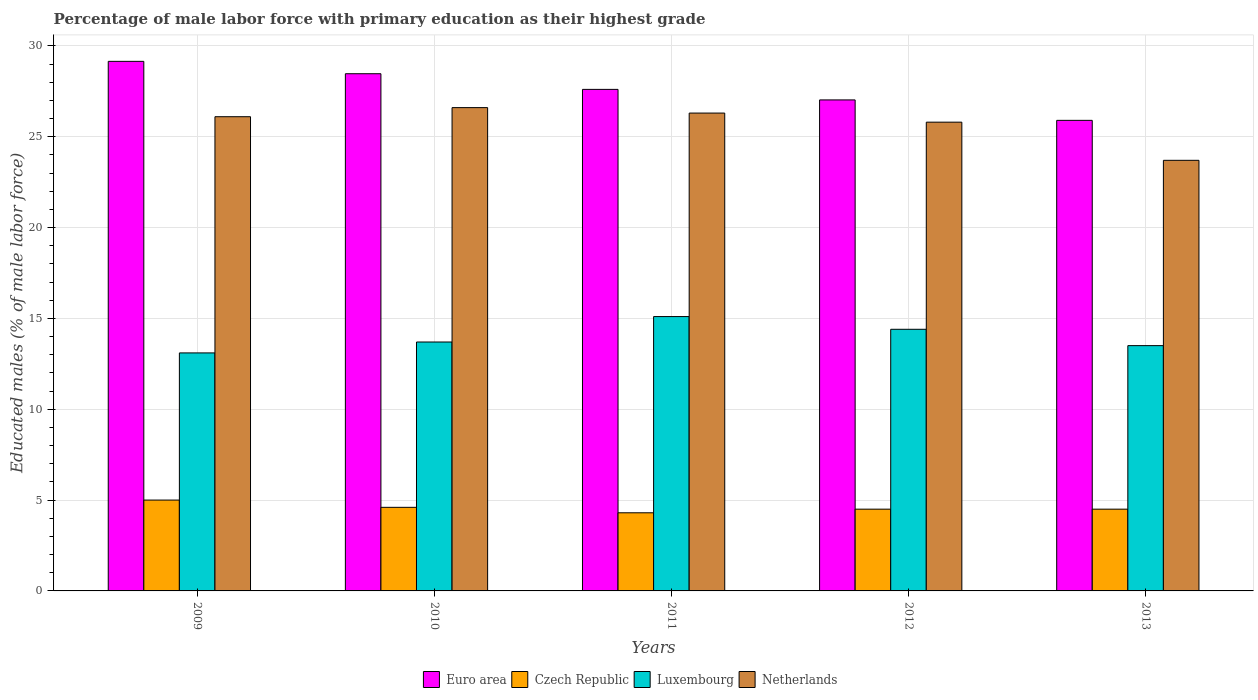How many different coloured bars are there?
Keep it short and to the point. 4. How many bars are there on the 5th tick from the left?
Give a very brief answer. 4. How many bars are there on the 1st tick from the right?
Provide a short and direct response. 4. In how many cases, is the number of bars for a given year not equal to the number of legend labels?
Offer a very short reply. 0. What is the percentage of male labor force with primary education in Netherlands in 2013?
Make the answer very short. 23.7. Across all years, what is the maximum percentage of male labor force with primary education in Luxembourg?
Ensure brevity in your answer.  15.1. Across all years, what is the minimum percentage of male labor force with primary education in Luxembourg?
Make the answer very short. 13.1. What is the total percentage of male labor force with primary education in Euro area in the graph?
Keep it short and to the point. 138.14. What is the difference between the percentage of male labor force with primary education in Luxembourg in 2009 and that in 2010?
Your answer should be very brief. -0.6. What is the difference between the percentage of male labor force with primary education in Euro area in 2010 and the percentage of male labor force with primary education in Netherlands in 2013?
Keep it short and to the point. 4.77. What is the average percentage of male labor force with primary education in Euro area per year?
Offer a very short reply. 27.63. In the year 2009, what is the difference between the percentage of male labor force with primary education in Czech Republic and percentage of male labor force with primary education in Luxembourg?
Provide a succinct answer. -8.1. What is the ratio of the percentage of male labor force with primary education in Euro area in 2009 to that in 2012?
Provide a succinct answer. 1.08. What is the difference between the highest and the second highest percentage of male labor force with primary education in Euro area?
Your answer should be very brief. 0.68. What is the difference between the highest and the lowest percentage of male labor force with primary education in Euro area?
Give a very brief answer. 3.25. Is the sum of the percentage of male labor force with primary education in Netherlands in 2009 and 2011 greater than the maximum percentage of male labor force with primary education in Euro area across all years?
Your answer should be very brief. Yes. What does the 1st bar from the left in 2012 represents?
Offer a terse response. Euro area. Is it the case that in every year, the sum of the percentage of male labor force with primary education in Luxembourg and percentage of male labor force with primary education in Czech Republic is greater than the percentage of male labor force with primary education in Netherlands?
Keep it short and to the point. No. How many bars are there?
Your answer should be compact. 20. How many years are there in the graph?
Your answer should be very brief. 5. Are the values on the major ticks of Y-axis written in scientific E-notation?
Provide a short and direct response. No. Does the graph contain grids?
Provide a short and direct response. Yes. How are the legend labels stacked?
Offer a terse response. Horizontal. What is the title of the graph?
Your answer should be very brief. Percentage of male labor force with primary education as their highest grade. Does "Turks and Caicos Islands" appear as one of the legend labels in the graph?
Ensure brevity in your answer.  No. What is the label or title of the Y-axis?
Keep it short and to the point. Educated males (% of male labor force). What is the Educated males (% of male labor force) of Euro area in 2009?
Offer a very short reply. 29.15. What is the Educated males (% of male labor force) of Czech Republic in 2009?
Offer a very short reply. 5. What is the Educated males (% of male labor force) in Luxembourg in 2009?
Keep it short and to the point. 13.1. What is the Educated males (% of male labor force) of Netherlands in 2009?
Ensure brevity in your answer.  26.1. What is the Educated males (% of male labor force) of Euro area in 2010?
Keep it short and to the point. 28.47. What is the Educated males (% of male labor force) in Czech Republic in 2010?
Give a very brief answer. 4.6. What is the Educated males (% of male labor force) in Luxembourg in 2010?
Offer a terse response. 13.7. What is the Educated males (% of male labor force) in Netherlands in 2010?
Ensure brevity in your answer.  26.6. What is the Educated males (% of male labor force) in Euro area in 2011?
Make the answer very short. 27.6. What is the Educated males (% of male labor force) of Czech Republic in 2011?
Give a very brief answer. 4.3. What is the Educated males (% of male labor force) in Luxembourg in 2011?
Offer a very short reply. 15.1. What is the Educated males (% of male labor force) of Netherlands in 2011?
Give a very brief answer. 26.3. What is the Educated males (% of male labor force) in Euro area in 2012?
Your answer should be compact. 27.02. What is the Educated males (% of male labor force) of Czech Republic in 2012?
Your response must be concise. 4.5. What is the Educated males (% of male labor force) in Luxembourg in 2012?
Give a very brief answer. 14.4. What is the Educated males (% of male labor force) in Netherlands in 2012?
Give a very brief answer. 25.8. What is the Educated males (% of male labor force) in Euro area in 2013?
Give a very brief answer. 25.9. What is the Educated males (% of male labor force) in Netherlands in 2013?
Your response must be concise. 23.7. Across all years, what is the maximum Educated males (% of male labor force) of Euro area?
Offer a very short reply. 29.15. Across all years, what is the maximum Educated males (% of male labor force) in Czech Republic?
Your response must be concise. 5. Across all years, what is the maximum Educated males (% of male labor force) of Luxembourg?
Provide a succinct answer. 15.1. Across all years, what is the maximum Educated males (% of male labor force) in Netherlands?
Make the answer very short. 26.6. Across all years, what is the minimum Educated males (% of male labor force) in Euro area?
Offer a terse response. 25.9. Across all years, what is the minimum Educated males (% of male labor force) of Czech Republic?
Your answer should be very brief. 4.3. Across all years, what is the minimum Educated males (% of male labor force) in Luxembourg?
Keep it short and to the point. 13.1. Across all years, what is the minimum Educated males (% of male labor force) in Netherlands?
Offer a terse response. 23.7. What is the total Educated males (% of male labor force) in Euro area in the graph?
Offer a very short reply. 138.14. What is the total Educated males (% of male labor force) of Czech Republic in the graph?
Provide a succinct answer. 22.9. What is the total Educated males (% of male labor force) of Luxembourg in the graph?
Offer a terse response. 69.8. What is the total Educated males (% of male labor force) in Netherlands in the graph?
Ensure brevity in your answer.  128.5. What is the difference between the Educated males (% of male labor force) of Euro area in 2009 and that in 2010?
Keep it short and to the point. 0.68. What is the difference between the Educated males (% of male labor force) of Czech Republic in 2009 and that in 2010?
Your response must be concise. 0.4. What is the difference between the Educated males (% of male labor force) in Euro area in 2009 and that in 2011?
Offer a very short reply. 1.54. What is the difference between the Educated males (% of male labor force) of Czech Republic in 2009 and that in 2011?
Your answer should be very brief. 0.7. What is the difference between the Educated males (% of male labor force) of Luxembourg in 2009 and that in 2011?
Provide a succinct answer. -2. What is the difference between the Educated males (% of male labor force) of Euro area in 2009 and that in 2012?
Offer a terse response. 2.12. What is the difference between the Educated males (% of male labor force) in Czech Republic in 2009 and that in 2012?
Keep it short and to the point. 0.5. What is the difference between the Educated males (% of male labor force) of Euro area in 2009 and that in 2013?
Provide a succinct answer. 3.25. What is the difference between the Educated males (% of male labor force) in Czech Republic in 2009 and that in 2013?
Provide a short and direct response. 0.5. What is the difference between the Educated males (% of male labor force) in Luxembourg in 2009 and that in 2013?
Offer a very short reply. -0.4. What is the difference between the Educated males (% of male labor force) of Netherlands in 2009 and that in 2013?
Your response must be concise. 2.4. What is the difference between the Educated males (% of male labor force) in Euro area in 2010 and that in 2011?
Give a very brief answer. 0.86. What is the difference between the Educated males (% of male labor force) of Czech Republic in 2010 and that in 2011?
Keep it short and to the point. 0.3. What is the difference between the Educated males (% of male labor force) of Euro area in 2010 and that in 2012?
Your answer should be compact. 1.44. What is the difference between the Educated males (% of male labor force) in Luxembourg in 2010 and that in 2012?
Your response must be concise. -0.7. What is the difference between the Educated males (% of male labor force) in Euro area in 2010 and that in 2013?
Ensure brevity in your answer.  2.57. What is the difference between the Educated males (% of male labor force) in Luxembourg in 2010 and that in 2013?
Provide a succinct answer. 0.2. What is the difference between the Educated males (% of male labor force) in Euro area in 2011 and that in 2012?
Provide a short and direct response. 0.58. What is the difference between the Educated males (% of male labor force) in Luxembourg in 2011 and that in 2012?
Make the answer very short. 0.7. What is the difference between the Educated males (% of male labor force) in Netherlands in 2011 and that in 2012?
Keep it short and to the point. 0.5. What is the difference between the Educated males (% of male labor force) of Euro area in 2011 and that in 2013?
Give a very brief answer. 1.7. What is the difference between the Educated males (% of male labor force) in Czech Republic in 2011 and that in 2013?
Offer a very short reply. -0.2. What is the difference between the Educated males (% of male labor force) of Netherlands in 2011 and that in 2013?
Make the answer very short. 2.6. What is the difference between the Educated males (% of male labor force) of Euro area in 2009 and the Educated males (% of male labor force) of Czech Republic in 2010?
Offer a terse response. 24.55. What is the difference between the Educated males (% of male labor force) of Euro area in 2009 and the Educated males (% of male labor force) of Luxembourg in 2010?
Ensure brevity in your answer.  15.45. What is the difference between the Educated males (% of male labor force) in Euro area in 2009 and the Educated males (% of male labor force) in Netherlands in 2010?
Give a very brief answer. 2.55. What is the difference between the Educated males (% of male labor force) of Czech Republic in 2009 and the Educated males (% of male labor force) of Netherlands in 2010?
Make the answer very short. -21.6. What is the difference between the Educated males (% of male labor force) of Euro area in 2009 and the Educated males (% of male labor force) of Czech Republic in 2011?
Give a very brief answer. 24.85. What is the difference between the Educated males (% of male labor force) in Euro area in 2009 and the Educated males (% of male labor force) in Luxembourg in 2011?
Keep it short and to the point. 14.05. What is the difference between the Educated males (% of male labor force) of Euro area in 2009 and the Educated males (% of male labor force) of Netherlands in 2011?
Keep it short and to the point. 2.85. What is the difference between the Educated males (% of male labor force) in Czech Republic in 2009 and the Educated males (% of male labor force) in Netherlands in 2011?
Provide a short and direct response. -21.3. What is the difference between the Educated males (% of male labor force) in Euro area in 2009 and the Educated males (% of male labor force) in Czech Republic in 2012?
Provide a succinct answer. 24.65. What is the difference between the Educated males (% of male labor force) in Euro area in 2009 and the Educated males (% of male labor force) in Luxembourg in 2012?
Provide a succinct answer. 14.75. What is the difference between the Educated males (% of male labor force) of Euro area in 2009 and the Educated males (% of male labor force) of Netherlands in 2012?
Give a very brief answer. 3.35. What is the difference between the Educated males (% of male labor force) in Czech Republic in 2009 and the Educated males (% of male labor force) in Luxembourg in 2012?
Keep it short and to the point. -9.4. What is the difference between the Educated males (% of male labor force) of Czech Republic in 2009 and the Educated males (% of male labor force) of Netherlands in 2012?
Give a very brief answer. -20.8. What is the difference between the Educated males (% of male labor force) in Euro area in 2009 and the Educated males (% of male labor force) in Czech Republic in 2013?
Your answer should be compact. 24.65. What is the difference between the Educated males (% of male labor force) of Euro area in 2009 and the Educated males (% of male labor force) of Luxembourg in 2013?
Your answer should be compact. 15.65. What is the difference between the Educated males (% of male labor force) of Euro area in 2009 and the Educated males (% of male labor force) of Netherlands in 2013?
Provide a succinct answer. 5.45. What is the difference between the Educated males (% of male labor force) of Czech Republic in 2009 and the Educated males (% of male labor force) of Luxembourg in 2013?
Your answer should be compact. -8.5. What is the difference between the Educated males (% of male labor force) of Czech Republic in 2009 and the Educated males (% of male labor force) of Netherlands in 2013?
Offer a very short reply. -18.7. What is the difference between the Educated males (% of male labor force) of Euro area in 2010 and the Educated males (% of male labor force) of Czech Republic in 2011?
Provide a succinct answer. 24.17. What is the difference between the Educated males (% of male labor force) of Euro area in 2010 and the Educated males (% of male labor force) of Luxembourg in 2011?
Keep it short and to the point. 13.37. What is the difference between the Educated males (% of male labor force) in Euro area in 2010 and the Educated males (% of male labor force) in Netherlands in 2011?
Keep it short and to the point. 2.17. What is the difference between the Educated males (% of male labor force) in Czech Republic in 2010 and the Educated males (% of male labor force) in Netherlands in 2011?
Keep it short and to the point. -21.7. What is the difference between the Educated males (% of male labor force) of Euro area in 2010 and the Educated males (% of male labor force) of Czech Republic in 2012?
Your answer should be very brief. 23.97. What is the difference between the Educated males (% of male labor force) of Euro area in 2010 and the Educated males (% of male labor force) of Luxembourg in 2012?
Offer a terse response. 14.07. What is the difference between the Educated males (% of male labor force) in Euro area in 2010 and the Educated males (% of male labor force) in Netherlands in 2012?
Give a very brief answer. 2.67. What is the difference between the Educated males (% of male labor force) of Czech Republic in 2010 and the Educated males (% of male labor force) of Luxembourg in 2012?
Your answer should be compact. -9.8. What is the difference between the Educated males (% of male labor force) in Czech Republic in 2010 and the Educated males (% of male labor force) in Netherlands in 2012?
Ensure brevity in your answer.  -21.2. What is the difference between the Educated males (% of male labor force) in Euro area in 2010 and the Educated males (% of male labor force) in Czech Republic in 2013?
Provide a succinct answer. 23.97. What is the difference between the Educated males (% of male labor force) of Euro area in 2010 and the Educated males (% of male labor force) of Luxembourg in 2013?
Ensure brevity in your answer.  14.97. What is the difference between the Educated males (% of male labor force) of Euro area in 2010 and the Educated males (% of male labor force) of Netherlands in 2013?
Provide a succinct answer. 4.77. What is the difference between the Educated males (% of male labor force) of Czech Republic in 2010 and the Educated males (% of male labor force) of Netherlands in 2013?
Your answer should be very brief. -19.1. What is the difference between the Educated males (% of male labor force) in Euro area in 2011 and the Educated males (% of male labor force) in Czech Republic in 2012?
Keep it short and to the point. 23.1. What is the difference between the Educated males (% of male labor force) in Euro area in 2011 and the Educated males (% of male labor force) in Luxembourg in 2012?
Give a very brief answer. 13.2. What is the difference between the Educated males (% of male labor force) in Euro area in 2011 and the Educated males (% of male labor force) in Netherlands in 2012?
Give a very brief answer. 1.8. What is the difference between the Educated males (% of male labor force) in Czech Republic in 2011 and the Educated males (% of male labor force) in Netherlands in 2012?
Your answer should be very brief. -21.5. What is the difference between the Educated males (% of male labor force) of Luxembourg in 2011 and the Educated males (% of male labor force) of Netherlands in 2012?
Provide a short and direct response. -10.7. What is the difference between the Educated males (% of male labor force) of Euro area in 2011 and the Educated males (% of male labor force) of Czech Republic in 2013?
Ensure brevity in your answer.  23.1. What is the difference between the Educated males (% of male labor force) in Euro area in 2011 and the Educated males (% of male labor force) in Luxembourg in 2013?
Keep it short and to the point. 14.1. What is the difference between the Educated males (% of male labor force) in Euro area in 2011 and the Educated males (% of male labor force) in Netherlands in 2013?
Make the answer very short. 3.9. What is the difference between the Educated males (% of male labor force) in Czech Republic in 2011 and the Educated males (% of male labor force) in Luxembourg in 2013?
Your answer should be very brief. -9.2. What is the difference between the Educated males (% of male labor force) of Czech Republic in 2011 and the Educated males (% of male labor force) of Netherlands in 2013?
Make the answer very short. -19.4. What is the difference between the Educated males (% of male labor force) in Luxembourg in 2011 and the Educated males (% of male labor force) in Netherlands in 2013?
Offer a very short reply. -8.6. What is the difference between the Educated males (% of male labor force) of Euro area in 2012 and the Educated males (% of male labor force) of Czech Republic in 2013?
Offer a very short reply. 22.52. What is the difference between the Educated males (% of male labor force) of Euro area in 2012 and the Educated males (% of male labor force) of Luxembourg in 2013?
Your response must be concise. 13.52. What is the difference between the Educated males (% of male labor force) of Euro area in 2012 and the Educated males (% of male labor force) of Netherlands in 2013?
Your response must be concise. 3.32. What is the difference between the Educated males (% of male labor force) of Czech Republic in 2012 and the Educated males (% of male labor force) of Luxembourg in 2013?
Offer a terse response. -9. What is the difference between the Educated males (% of male labor force) of Czech Republic in 2012 and the Educated males (% of male labor force) of Netherlands in 2013?
Provide a short and direct response. -19.2. What is the difference between the Educated males (% of male labor force) in Luxembourg in 2012 and the Educated males (% of male labor force) in Netherlands in 2013?
Offer a very short reply. -9.3. What is the average Educated males (% of male labor force) in Euro area per year?
Offer a very short reply. 27.63. What is the average Educated males (% of male labor force) in Czech Republic per year?
Provide a succinct answer. 4.58. What is the average Educated males (% of male labor force) in Luxembourg per year?
Your answer should be very brief. 13.96. What is the average Educated males (% of male labor force) of Netherlands per year?
Ensure brevity in your answer.  25.7. In the year 2009, what is the difference between the Educated males (% of male labor force) of Euro area and Educated males (% of male labor force) of Czech Republic?
Offer a very short reply. 24.15. In the year 2009, what is the difference between the Educated males (% of male labor force) in Euro area and Educated males (% of male labor force) in Luxembourg?
Your response must be concise. 16.05. In the year 2009, what is the difference between the Educated males (% of male labor force) in Euro area and Educated males (% of male labor force) in Netherlands?
Your answer should be very brief. 3.05. In the year 2009, what is the difference between the Educated males (% of male labor force) of Czech Republic and Educated males (% of male labor force) of Luxembourg?
Provide a short and direct response. -8.1. In the year 2009, what is the difference between the Educated males (% of male labor force) in Czech Republic and Educated males (% of male labor force) in Netherlands?
Provide a succinct answer. -21.1. In the year 2009, what is the difference between the Educated males (% of male labor force) in Luxembourg and Educated males (% of male labor force) in Netherlands?
Keep it short and to the point. -13. In the year 2010, what is the difference between the Educated males (% of male labor force) in Euro area and Educated males (% of male labor force) in Czech Republic?
Make the answer very short. 23.87. In the year 2010, what is the difference between the Educated males (% of male labor force) in Euro area and Educated males (% of male labor force) in Luxembourg?
Provide a short and direct response. 14.77. In the year 2010, what is the difference between the Educated males (% of male labor force) in Euro area and Educated males (% of male labor force) in Netherlands?
Offer a terse response. 1.87. In the year 2010, what is the difference between the Educated males (% of male labor force) in Czech Republic and Educated males (% of male labor force) in Luxembourg?
Your answer should be compact. -9.1. In the year 2010, what is the difference between the Educated males (% of male labor force) in Luxembourg and Educated males (% of male labor force) in Netherlands?
Offer a terse response. -12.9. In the year 2011, what is the difference between the Educated males (% of male labor force) of Euro area and Educated males (% of male labor force) of Czech Republic?
Your response must be concise. 23.3. In the year 2011, what is the difference between the Educated males (% of male labor force) in Euro area and Educated males (% of male labor force) in Luxembourg?
Give a very brief answer. 12.5. In the year 2011, what is the difference between the Educated males (% of male labor force) in Euro area and Educated males (% of male labor force) in Netherlands?
Make the answer very short. 1.3. In the year 2011, what is the difference between the Educated males (% of male labor force) of Czech Republic and Educated males (% of male labor force) of Luxembourg?
Provide a short and direct response. -10.8. In the year 2011, what is the difference between the Educated males (% of male labor force) in Czech Republic and Educated males (% of male labor force) in Netherlands?
Provide a succinct answer. -22. In the year 2011, what is the difference between the Educated males (% of male labor force) in Luxembourg and Educated males (% of male labor force) in Netherlands?
Keep it short and to the point. -11.2. In the year 2012, what is the difference between the Educated males (% of male labor force) in Euro area and Educated males (% of male labor force) in Czech Republic?
Keep it short and to the point. 22.52. In the year 2012, what is the difference between the Educated males (% of male labor force) in Euro area and Educated males (% of male labor force) in Luxembourg?
Offer a terse response. 12.62. In the year 2012, what is the difference between the Educated males (% of male labor force) of Euro area and Educated males (% of male labor force) of Netherlands?
Make the answer very short. 1.22. In the year 2012, what is the difference between the Educated males (% of male labor force) in Czech Republic and Educated males (% of male labor force) in Netherlands?
Offer a very short reply. -21.3. In the year 2013, what is the difference between the Educated males (% of male labor force) of Euro area and Educated males (% of male labor force) of Czech Republic?
Your answer should be compact. 21.4. In the year 2013, what is the difference between the Educated males (% of male labor force) of Euro area and Educated males (% of male labor force) of Luxembourg?
Give a very brief answer. 12.4. In the year 2013, what is the difference between the Educated males (% of male labor force) of Euro area and Educated males (% of male labor force) of Netherlands?
Your answer should be very brief. 2.2. In the year 2013, what is the difference between the Educated males (% of male labor force) in Czech Republic and Educated males (% of male labor force) in Luxembourg?
Your answer should be very brief. -9. In the year 2013, what is the difference between the Educated males (% of male labor force) in Czech Republic and Educated males (% of male labor force) in Netherlands?
Make the answer very short. -19.2. What is the ratio of the Educated males (% of male labor force) in Euro area in 2009 to that in 2010?
Give a very brief answer. 1.02. What is the ratio of the Educated males (% of male labor force) of Czech Republic in 2009 to that in 2010?
Your response must be concise. 1.09. What is the ratio of the Educated males (% of male labor force) of Luxembourg in 2009 to that in 2010?
Your response must be concise. 0.96. What is the ratio of the Educated males (% of male labor force) in Netherlands in 2009 to that in 2010?
Ensure brevity in your answer.  0.98. What is the ratio of the Educated males (% of male labor force) of Euro area in 2009 to that in 2011?
Your response must be concise. 1.06. What is the ratio of the Educated males (% of male labor force) of Czech Republic in 2009 to that in 2011?
Keep it short and to the point. 1.16. What is the ratio of the Educated males (% of male labor force) of Luxembourg in 2009 to that in 2011?
Your answer should be very brief. 0.87. What is the ratio of the Educated males (% of male labor force) of Netherlands in 2009 to that in 2011?
Offer a terse response. 0.99. What is the ratio of the Educated males (% of male labor force) of Euro area in 2009 to that in 2012?
Your response must be concise. 1.08. What is the ratio of the Educated males (% of male labor force) in Luxembourg in 2009 to that in 2012?
Provide a succinct answer. 0.91. What is the ratio of the Educated males (% of male labor force) of Netherlands in 2009 to that in 2012?
Offer a very short reply. 1.01. What is the ratio of the Educated males (% of male labor force) in Euro area in 2009 to that in 2013?
Keep it short and to the point. 1.13. What is the ratio of the Educated males (% of male labor force) of Czech Republic in 2009 to that in 2013?
Provide a succinct answer. 1.11. What is the ratio of the Educated males (% of male labor force) in Luxembourg in 2009 to that in 2013?
Provide a short and direct response. 0.97. What is the ratio of the Educated males (% of male labor force) in Netherlands in 2009 to that in 2013?
Give a very brief answer. 1.1. What is the ratio of the Educated males (% of male labor force) in Euro area in 2010 to that in 2011?
Ensure brevity in your answer.  1.03. What is the ratio of the Educated males (% of male labor force) in Czech Republic in 2010 to that in 2011?
Provide a succinct answer. 1.07. What is the ratio of the Educated males (% of male labor force) in Luxembourg in 2010 to that in 2011?
Your answer should be very brief. 0.91. What is the ratio of the Educated males (% of male labor force) of Netherlands in 2010 to that in 2011?
Give a very brief answer. 1.01. What is the ratio of the Educated males (% of male labor force) in Euro area in 2010 to that in 2012?
Ensure brevity in your answer.  1.05. What is the ratio of the Educated males (% of male labor force) in Czech Republic in 2010 to that in 2012?
Your answer should be compact. 1.02. What is the ratio of the Educated males (% of male labor force) of Luxembourg in 2010 to that in 2012?
Offer a terse response. 0.95. What is the ratio of the Educated males (% of male labor force) in Netherlands in 2010 to that in 2012?
Your answer should be compact. 1.03. What is the ratio of the Educated males (% of male labor force) in Euro area in 2010 to that in 2013?
Offer a terse response. 1.1. What is the ratio of the Educated males (% of male labor force) in Czech Republic in 2010 to that in 2013?
Keep it short and to the point. 1.02. What is the ratio of the Educated males (% of male labor force) of Luxembourg in 2010 to that in 2013?
Give a very brief answer. 1.01. What is the ratio of the Educated males (% of male labor force) of Netherlands in 2010 to that in 2013?
Keep it short and to the point. 1.12. What is the ratio of the Educated males (% of male labor force) in Euro area in 2011 to that in 2012?
Provide a short and direct response. 1.02. What is the ratio of the Educated males (% of male labor force) in Czech Republic in 2011 to that in 2012?
Provide a succinct answer. 0.96. What is the ratio of the Educated males (% of male labor force) in Luxembourg in 2011 to that in 2012?
Keep it short and to the point. 1.05. What is the ratio of the Educated males (% of male labor force) of Netherlands in 2011 to that in 2012?
Offer a very short reply. 1.02. What is the ratio of the Educated males (% of male labor force) of Euro area in 2011 to that in 2013?
Provide a short and direct response. 1.07. What is the ratio of the Educated males (% of male labor force) of Czech Republic in 2011 to that in 2013?
Provide a short and direct response. 0.96. What is the ratio of the Educated males (% of male labor force) in Luxembourg in 2011 to that in 2013?
Make the answer very short. 1.12. What is the ratio of the Educated males (% of male labor force) in Netherlands in 2011 to that in 2013?
Offer a terse response. 1.11. What is the ratio of the Educated males (% of male labor force) in Euro area in 2012 to that in 2013?
Your answer should be compact. 1.04. What is the ratio of the Educated males (% of male labor force) of Czech Republic in 2012 to that in 2013?
Keep it short and to the point. 1. What is the ratio of the Educated males (% of male labor force) of Luxembourg in 2012 to that in 2013?
Provide a short and direct response. 1.07. What is the ratio of the Educated males (% of male labor force) in Netherlands in 2012 to that in 2013?
Give a very brief answer. 1.09. What is the difference between the highest and the second highest Educated males (% of male labor force) in Euro area?
Provide a succinct answer. 0.68. What is the difference between the highest and the second highest Educated males (% of male labor force) in Luxembourg?
Your answer should be compact. 0.7. What is the difference between the highest and the second highest Educated males (% of male labor force) in Netherlands?
Make the answer very short. 0.3. What is the difference between the highest and the lowest Educated males (% of male labor force) in Euro area?
Your answer should be compact. 3.25. What is the difference between the highest and the lowest Educated males (% of male labor force) of Luxembourg?
Provide a short and direct response. 2. What is the difference between the highest and the lowest Educated males (% of male labor force) of Netherlands?
Provide a succinct answer. 2.9. 